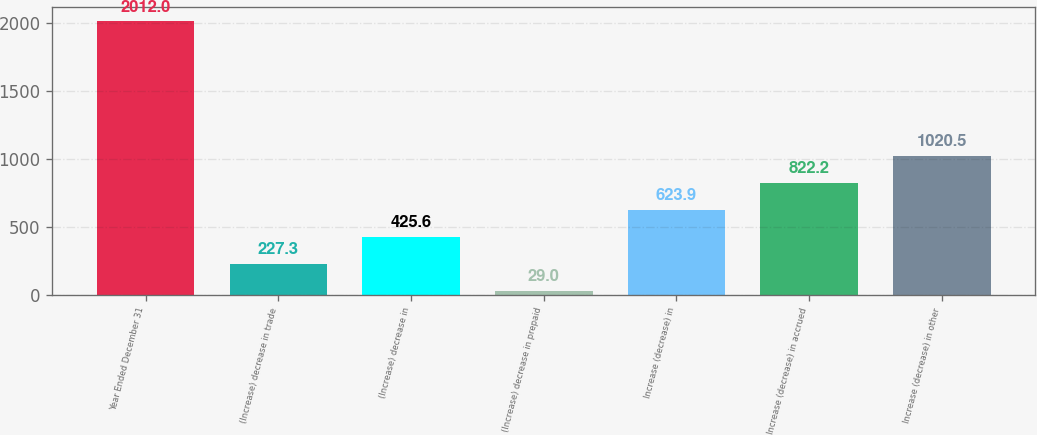Convert chart to OTSL. <chart><loc_0><loc_0><loc_500><loc_500><bar_chart><fcel>Year Ended December 31<fcel>(Increase) decrease in trade<fcel>(Increase) decrease in<fcel>(Increase) decrease in prepaid<fcel>Increase (decrease) in<fcel>Increase (decrease) in accrued<fcel>Increase (decrease) in other<nl><fcel>2012<fcel>227.3<fcel>425.6<fcel>29<fcel>623.9<fcel>822.2<fcel>1020.5<nl></chart> 